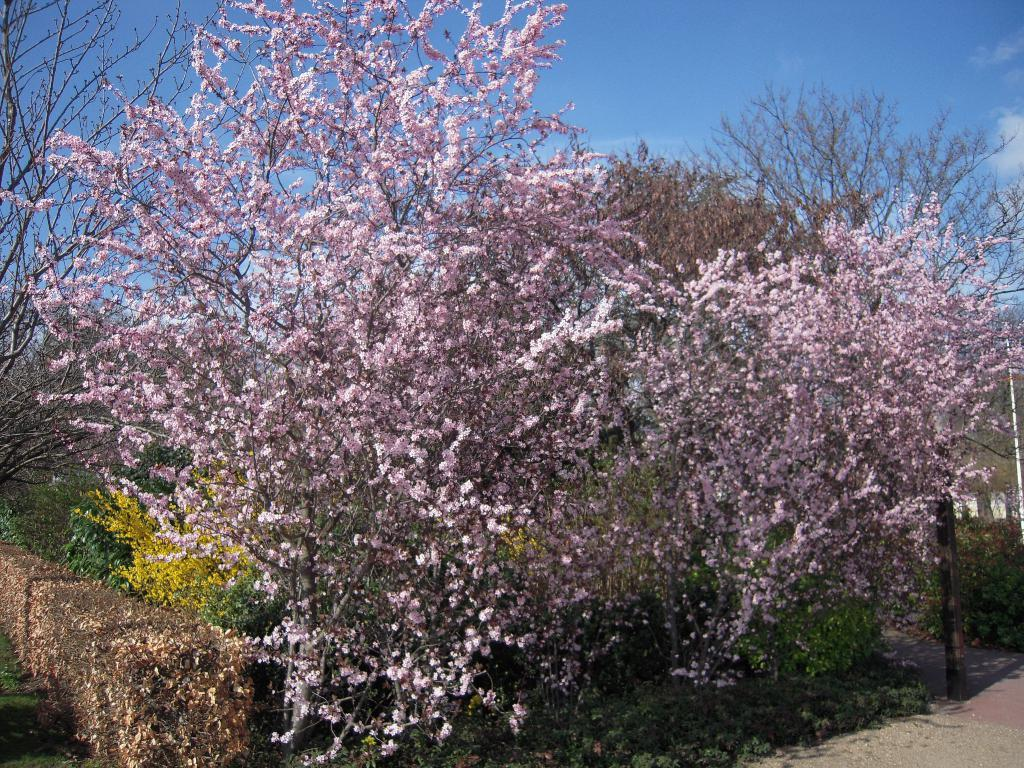What type of vegetation can be seen in the image? There are trees, plants, and flowers in the image. What else is present in the image besides vegetation? There is a rod in the image. What can be seen in the background of the image? The sky is visible in the background of the image. How does the zephyr affect the plants in the image? There is no zephyr present in the image, so its effect on the plants cannot be determined. 